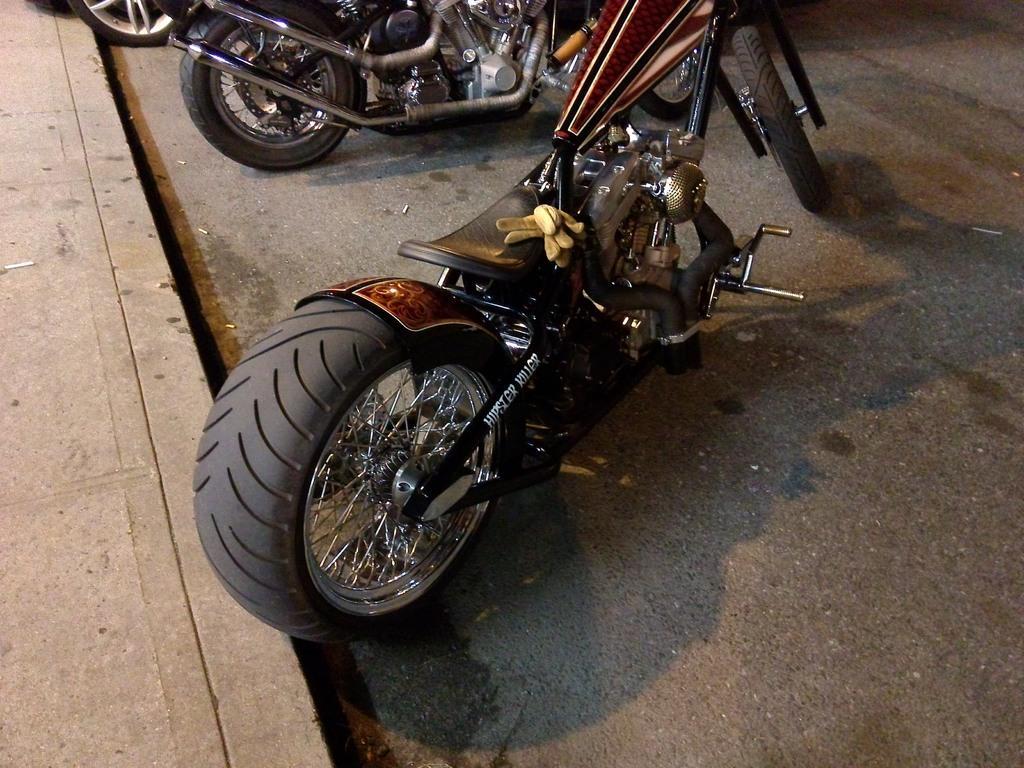How would you summarize this image in a sentence or two? In this image, we can see vehicles are parked on the road. Left side of the image, there is a walkway. 